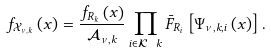<formula> <loc_0><loc_0><loc_500><loc_500>f _ { \mathcal { X } _ { \nu , k } } \left ( x \right ) = \frac { f _ { R _ { k } } \left ( x \right ) } { \mathcal { A } _ { \nu , k } } \prod _ { i \in \mathcal { K } \ k } \bar { F } _ { R _ { i } } \left [ \Psi _ { \nu , k , i } \left ( x \right ) \right ] .</formula> 